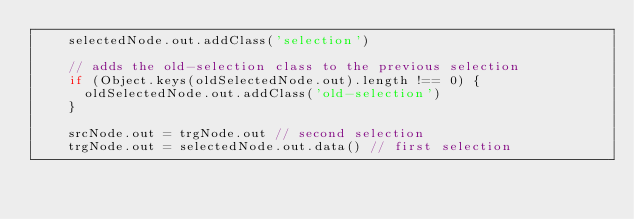<code> <loc_0><loc_0><loc_500><loc_500><_JavaScript_>    selectedNode.out.addClass('selection')

    // adds the old-selection class to the previous selection
    if (Object.keys(oldSelectedNode.out).length !== 0) {
      oldSelectedNode.out.addClass('old-selection')
    }

    srcNode.out = trgNode.out // second selection
    trgNode.out = selectedNode.out.data() // first selection
</code> 